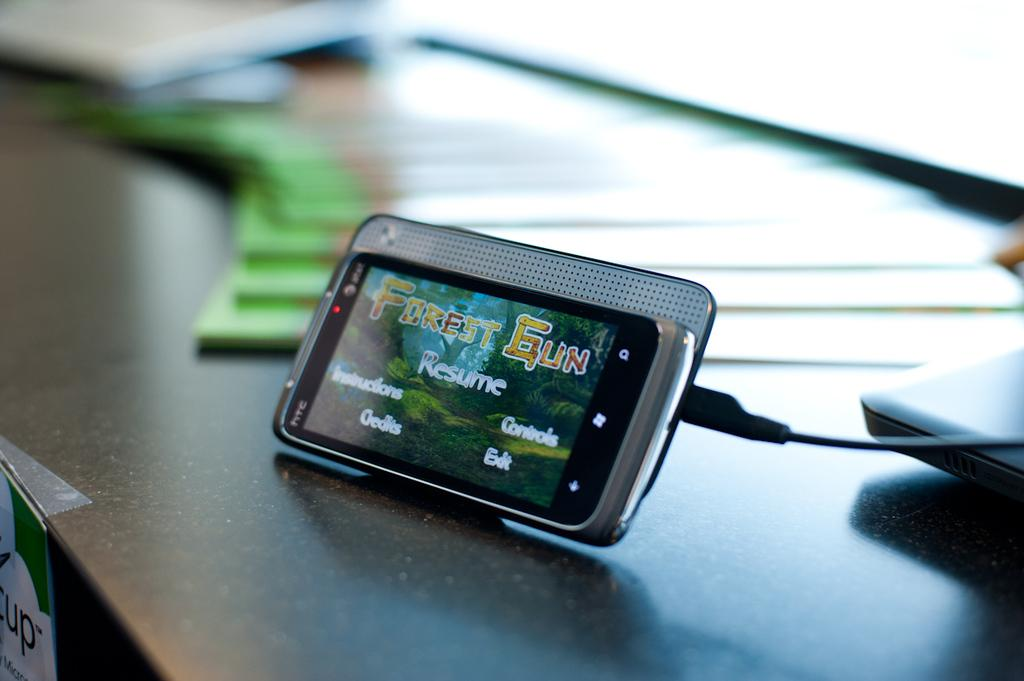Provide a one-sentence caption for the provided image. htc phone sitting at an angle with forest gun game on the screen. 